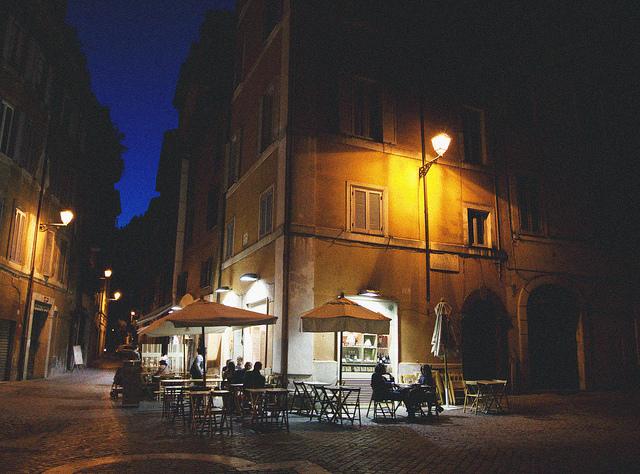How many people are sitting down?
Write a very short answer. 7. How many humans are visible in this photo?
Write a very short answer. 9. Is it night?
Be succinct. Yes. What type of boat is seen on far right in background?
Be succinct. None. What are the people in the picture doing?
Be succinct. Eating. Do all the windows have shutters?
Concise answer only. No. Is there a clock on the tower?
Keep it brief. No. What time these shops open?
Be succinct. 9 am. Are there any people in the street?
Keep it brief. Yes. What color is the light?
Keep it brief. Yellow. 